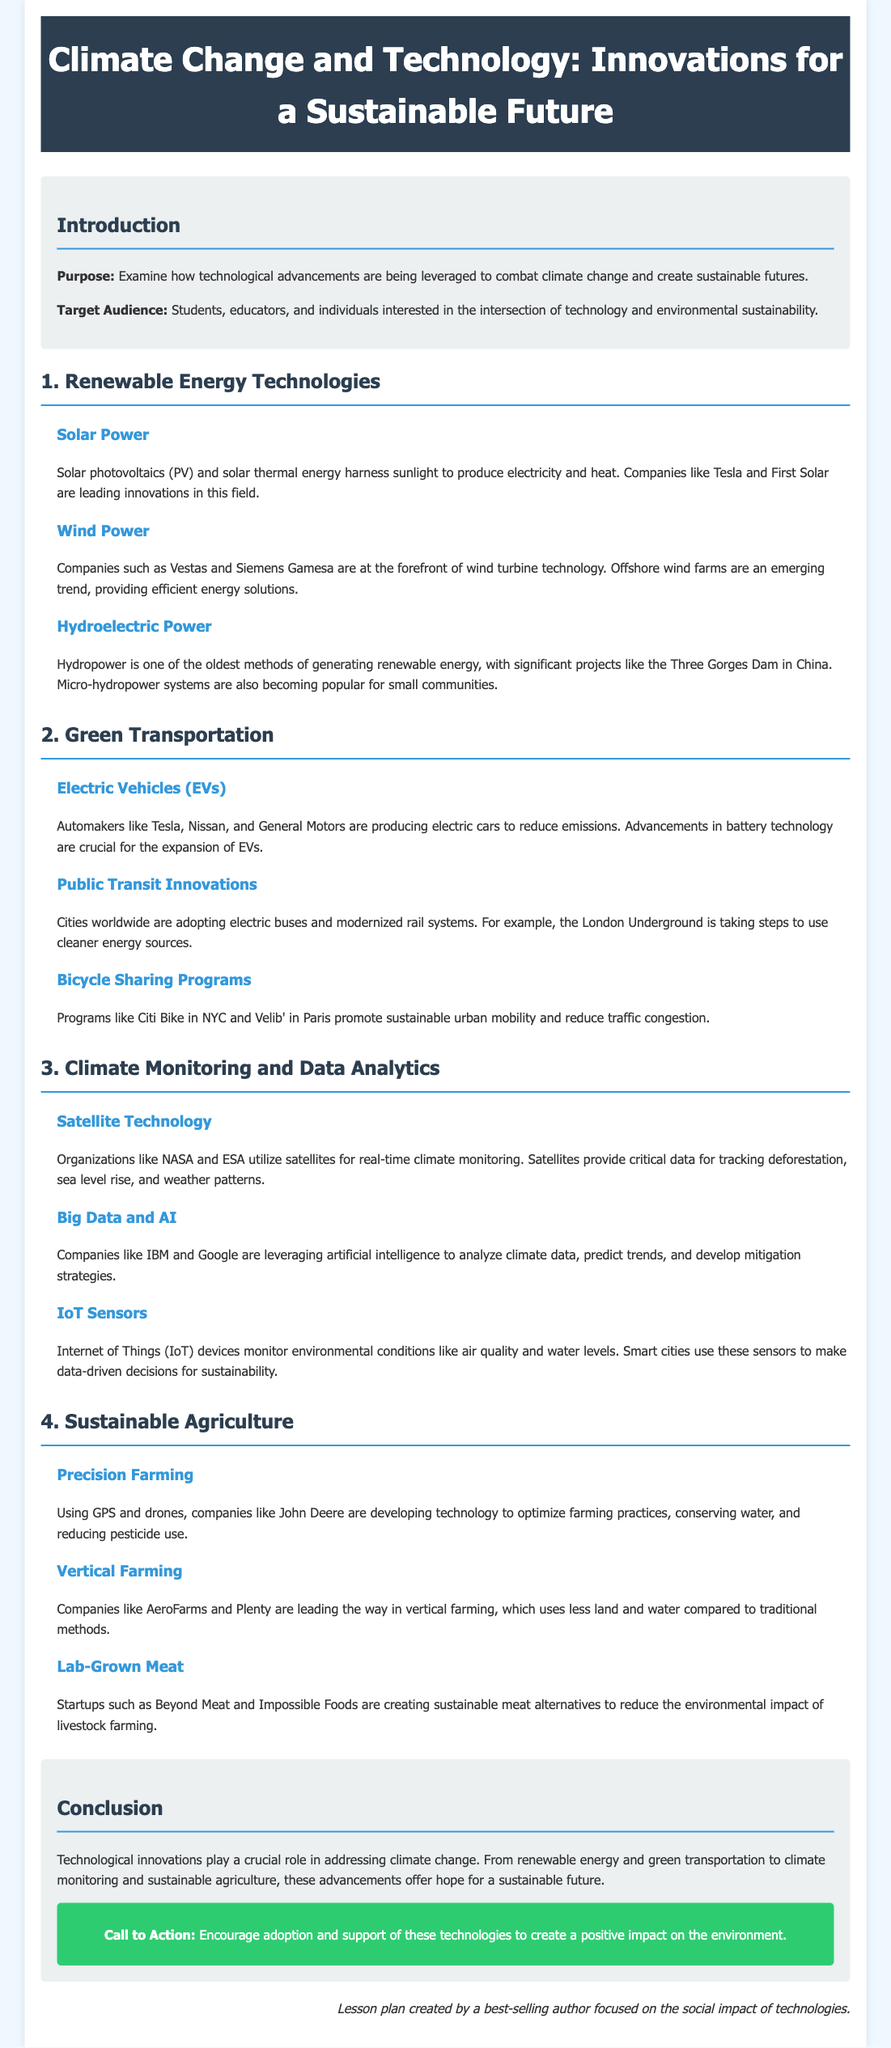what is the title of the lesson plan? The title of the lesson plan is clearly stated at the top of the document.
Answer: Climate Change and Technology: Innovations for a Sustainable Future who are the target audience for the lesson plan? The target audience is specified in the introduction section of the document.
Answer: Students, educators, and individuals interested in the intersection of technology and environmental sustainability which company is leading innovations in solar power? The section on solar power mentions specific companies involved in this technology.
Answer: Tesla what kind of vehicles are discussed under green transportation? The section on green transportation highlights a specific type of vehicle that contributes to emissions reduction.
Answer: Electric Vehicles (EVs) what technology is used for real-time climate monitoring? The document provides information on the technology used for climate monitoring in the climate monitoring section.
Answer: Satellite Technology how many sections are there in the lesson plan? The total number of sections is listed in the structure of the document.
Answer: 4 what is the primary focus of the section on sustainable agriculture? The sustainable agriculture section outlines different topics all related to agriculture.
Answer: Precision Farming which company is associated with vertical farming? The section on vertical farming mentions specific companies that are leading this innovation.
Answer: AeroFarms what is the call to action at the end of the lesson plan? The conclusion section contains a specific statement encouraging actions related to technologies.
Answer: Encourage adoption and support of these technologies to create a positive impact on the environment 